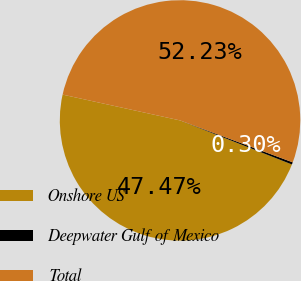Convert chart. <chart><loc_0><loc_0><loc_500><loc_500><pie_chart><fcel>Onshore US<fcel>Deepwater Gulf of Mexico<fcel>Total<nl><fcel>47.47%<fcel>0.3%<fcel>52.22%<nl></chart> 